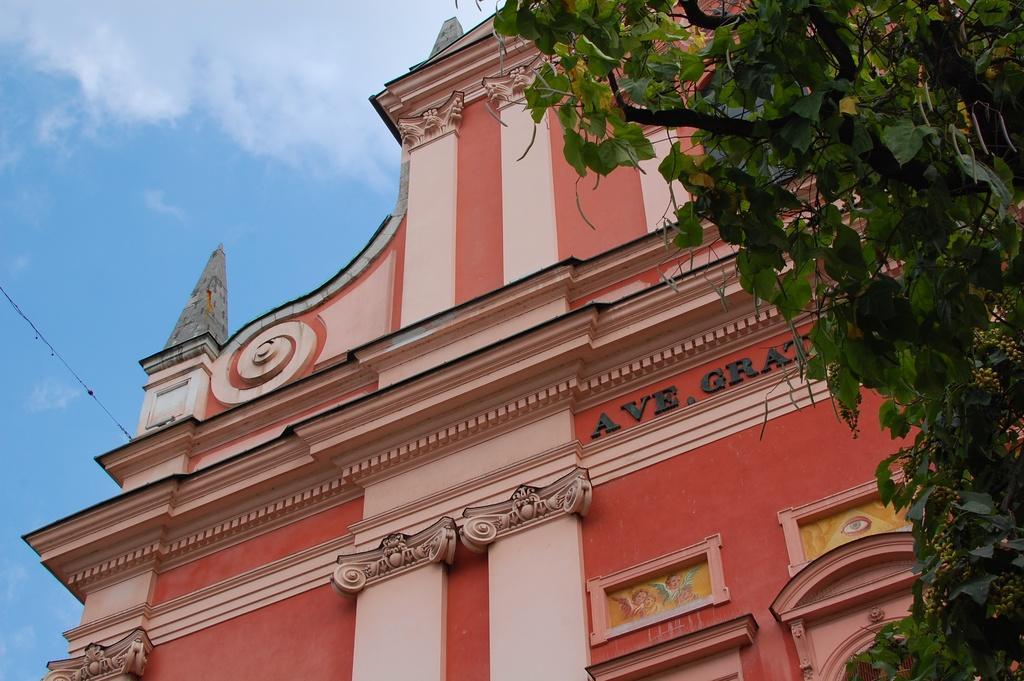In one or two sentences, can you explain what this image depicts? In this image we can see one big building which looks like a church, one big tree on the right side of the image, one wire attached to the building, one object attached to the building, some text and images on the building. At the top there is the cloudy sky. 